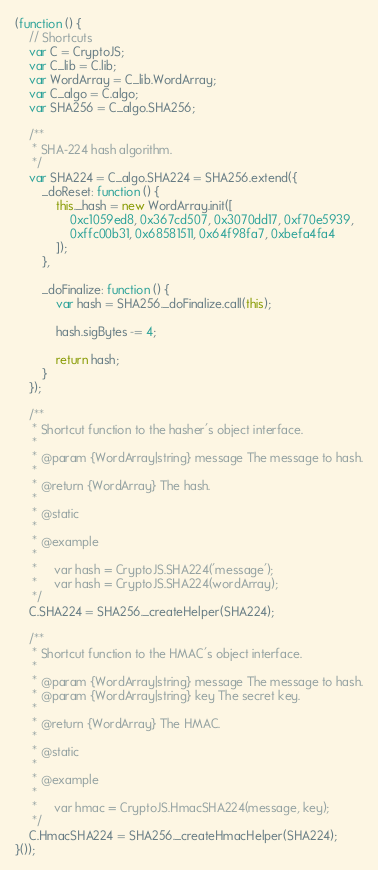Convert code to text. <code><loc_0><loc_0><loc_500><loc_500><_JavaScript_>(function () {
    // Shortcuts
    var C = CryptoJS;
    var C_lib = C.lib;
    var WordArray = C_lib.WordArray;
    var C_algo = C.algo;
    var SHA256 = C_algo.SHA256;

    /**
     * SHA-224 hash algorithm.
     */
    var SHA224 = C_algo.SHA224 = SHA256.extend({
        _doReset: function () {
            this._hash = new WordArray.init([
                0xc1059ed8, 0x367cd507, 0x3070dd17, 0xf70e5939,
                0xffc00b31, 0x68581511, 0x64f98fa7, 0xbefa4fa4
            ]);
        },

        _doFinalize: function () {
            var hash = SHA256._doFinalize.call(this);

            hash.sigBytes -= 4;

            return hash;
        }
    });

    /**
     * Shortcut function to the hasher's object interface.
     *
     * @param {WordArray|string} message The message to hash.
     *
     * @return {WordArray} The hash.
     *
     * @static
     *
     * @example
     *
     *     var hash = CryptoJS.SHA224('message');
     *     var hash = CryptoJS.SHA224(wordArray);
     */
    C.SHA224 = SHA256._createHelper(SHA224);

    /**
     * Shortcut function to the HMAC's object interface.
     *
     * @param {WordArray|string} message The message to hash.
     * @param {WordArray|string} key The secret key.
     *
     * @return {WordArray} The HMAC.
     *
     * @static
     *
     * @example
     *
     *     var hmac = CryptoJS.HmacSHA224(message, key);
     */
    C.HmacSHA224 = SHA256._createHmacHelper(SHA224);
}());
</code> 